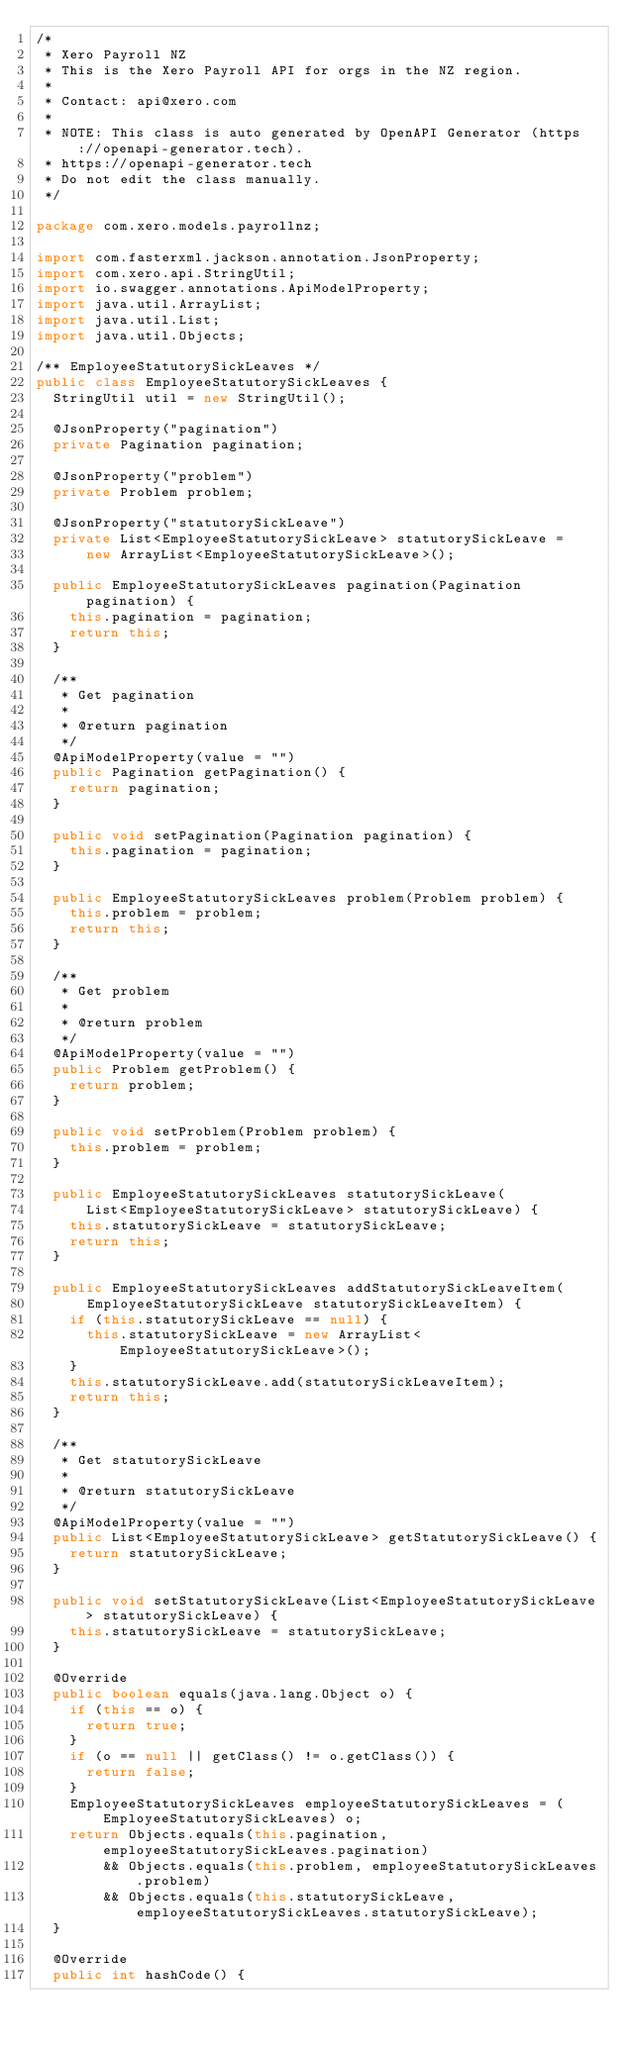Convert code to text. <code><loc_0><loc_0><loc_500><loc_500><_Java_>/*
 * Xero Payroll NZ
 * This is the Xero Payroll API for orgs in the NZ region.
 *
 * Contact: api@xero.com
 *
 * NOTE: This class is auto generated by OpenAPI Generator (https://openapi-generator.tech).
 * https://openapi-generator.tech
 * Do not edit the class manually.
 */

package com.xero.models.payrollnz;

import com.fasterxml.jackson.annotation.JsonProperty;
import com.xero.api.StringUtil;
import io.swagger.annotations.ApiModelProperty;
import java.util.ArrayList;
import java.util.List;
import java.util.Objects;

/** EmployeeStatutorySickLeaves */
public class EmployeeStatutorySickLeaves {
  StringUtil util = new StringUtil();

  @JsonProperty("pagination")
  private Pagination pagination;

  @JsonProperty("problem")
  private Problem problem;

  @JsonProperty("statutorySickLeave")
  private List<EmployeeStatutorySickLeave> statutorySickLeave =
      new ArrayList<EmployeeStatutorySickLeave>();

  public EmployeeStatutorySickLeaves pagination(Pagination pagination) {
    this.pagination = pagination;
    return this;
  }

  /**
   * Get pagination
   *
   * @return pagination
   */
  @ApiModelProperty(value = "")
  public Pagination getPagination() {
    return pagination;
  }

  public void setPagination(Pagination pagination) {
    this.pagination = pagination;
  }

  public EmployeeStatutorySickLeaves problem(Problem problem) {
    this.problem = problem;
    return this;
  }

  /**
   * Get problem
   *
   * @return problem
   */
  @ApiModelProperty(value = "")
  public Problem getProblem() {
    return problem;
  }

  public void setProblem(Problem problem) {
    this.problem = problem;
  }

  public EmployeeStatutorySickLeaves statutorySickLeave(
      List<EmployeeStatutorySickLeave> statutorySickLeave) {
    this.statutorySickLeave = statutorySickLeave;
    return this;
  }

  public EmployeeStatutorySickLeaves addStatutorySickLeaveItem(
      EmployeeStatutorySickLeave statutorySickLeaveItem) {
    if (this.statutorySickLeave == null) {
      this.statutorySickLeave = new ArrayList<EmployeeStatutorySickLeave>();
    }
    this.statutorySickLeave.add(statutorySickLeaveItem);
    return this;
  }

  /**
   * Get statutorySickLeave
   *
   * @return statutorySickLeave
   */
  @ApiModelProperty(value = "")
  public List<EmployeeStatutorySickLeave> getStatutorySickLeave() {
    return statutorySickLeave;
  }

  public void setStatutorySickLeave(List<EmployeeStatutorySickLeave> statutorySickLeave) {
    this.statutorySickLeave = statutorySickLeave;
  }

  @Override
  public boolean equals(java.lang.Object o) {
    if (this == o) {
      return true;
    }
    if (o == null || getClass() != o.getClass()) {
      return false;
    }
    EmployeeStatutorySickLeaves employeeStatutorySickLeaves = (EmployeeStatutorySickLeaves) o;
    return Objects.equals(this.pagination, employeeStatutorySickLeaves.pagination)
        && Objects.equals(this.problem, employeeStatutorySickLeaves.problem)
        && Objects.equals(this.statutorySickLeave, employeeStatutorySickLeaves.statutorySickLeave);
  }

  @Override
  public int hashCode() {</code> 